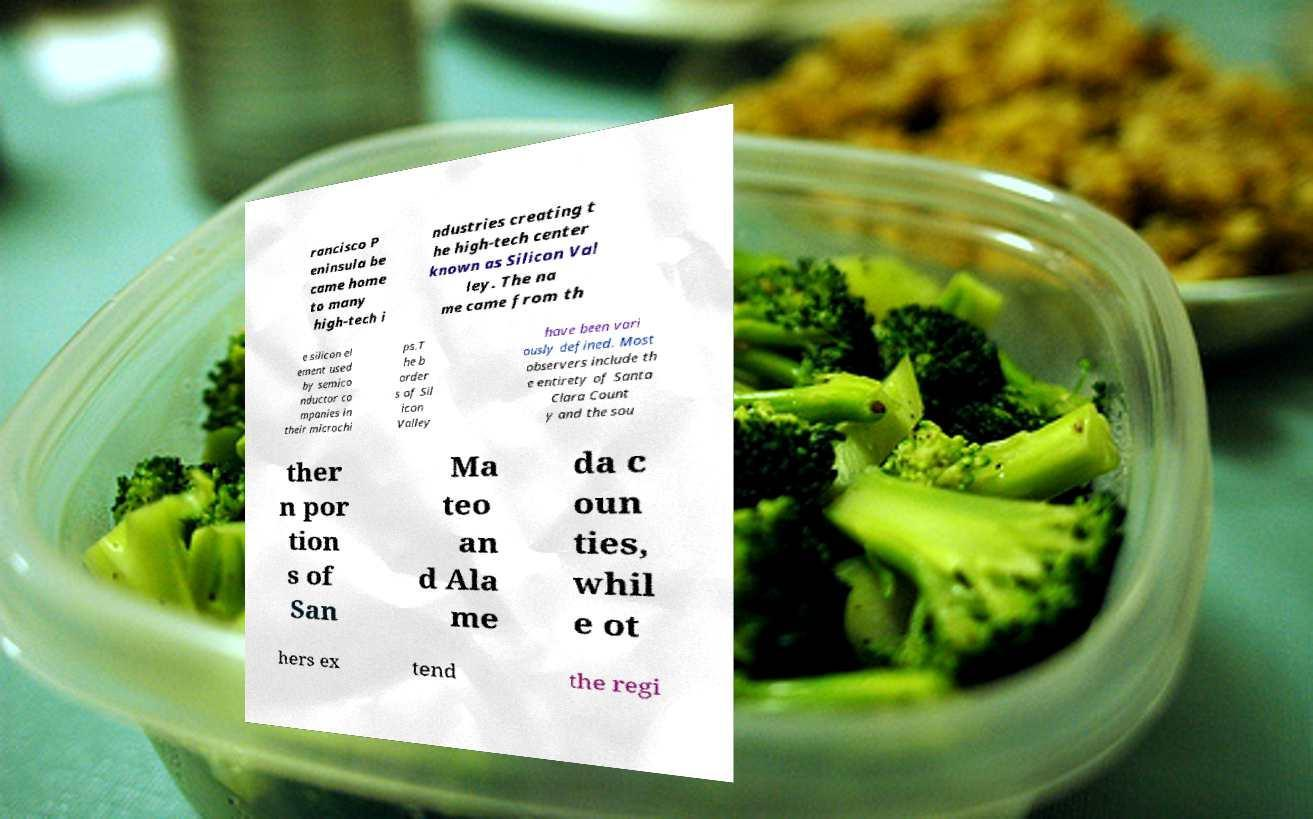Please read and relay the text visible in this image. What does it say? rancisco P eninsula be came home to many high-tech i ndustries creating t he high-tech center known as Silicon Val ley. The na me came from th e silicon el ement used by semico nductor co mpanies in their microchi ps.T he b order s of Sil icon Valley have been vari ously defined. Most observers include th e entirety of Santa Clara Count y and the sou ther n por tion s of San Ma teo an d Ala me da c oun ties, whil e ot hers ex tend the regi 